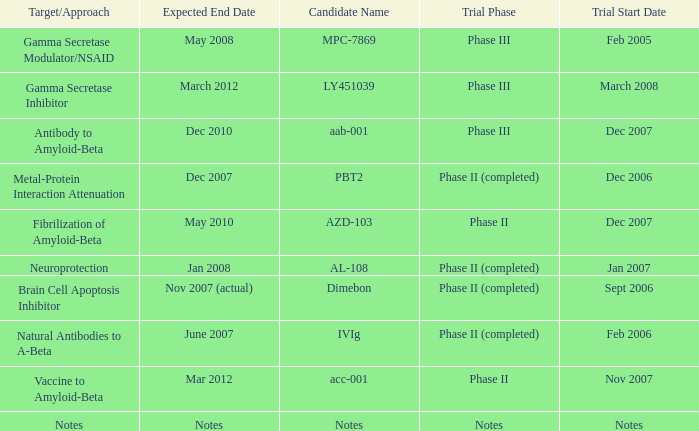What is Candidate Name, when Target/Approach is "vaccine to amyloid-beta"? Acc-001. 